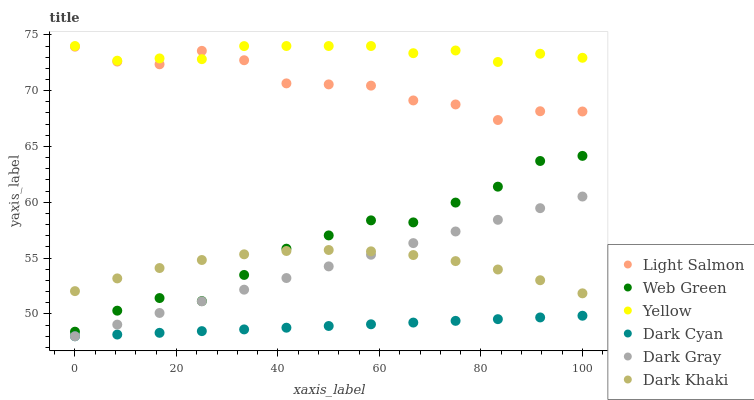Does Dark Cyan have the minimum area under the curve?
Answer yes or no. Yes. Does Yellow have the maximum area under the curve?
Answer yes or no. Yes. Does Light Salmon have the minimum area under the curve?
Answer yes or no. No. Does Light Salmon have the maximum area under the curve?
Answer yes or no. No. Is Dark Cyan the smoothest?
Answer yes or no. Yes. Is Light Salmon the roughest?
Answer yes or no. Yes. Is Yellow the smoothest?
Answer yes or no. No. Is Yellow the roughest?
Answer yes or no. No. Does Dark Gray have the lowest value?
Answer yes or no. Yes. Does Light Salmon have the lowest value?
Answer yes or no. No. Does Yellow have the highest value?
Answer yes or no. Yes. Does Light Salmon have the highest value?
Answer yes or no. No. Is Dark Gray less than Yellow?
Answer yes or no. Yes. Is Light Salmon greater than Dark Khaki?
Answer yes or no. Yes. Does Dark Khaki intersect Web Green?
Answer yes or no. Yes. Is Dark Khaki less than Web Green?
Answer yes or no. No. Is Dark Khaki greater than Web Green?
Answer yes or no. No. Does Dark Gray intersect Yellow?
Answer yes or no. No. 